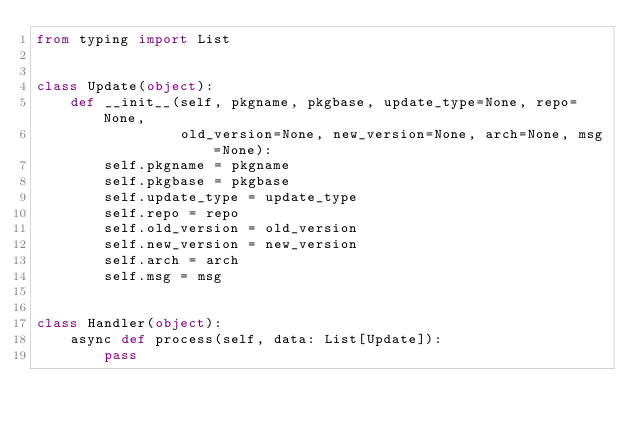Convert code to text. <code><loc_0><loc_0><loc_500><loc_500><_Python_>from typing import List


class Update(object):
    def __init__(self, pkgname, pkgbase, update_type=None, repo=None,
                 old_version=None, new_version=None, arch=None, msg=None):
        self.pkgname = pkgname
        self.pkgbase = pkgbase
        self.update_type = update_type
        self.repo = repo
        self.old_version = old_version
        self.new_version = new_version
        self.arch = arch
        self.msg = msg


class Handler(object):
    async def process(self, data: List[Update]):
        pass
</code> 